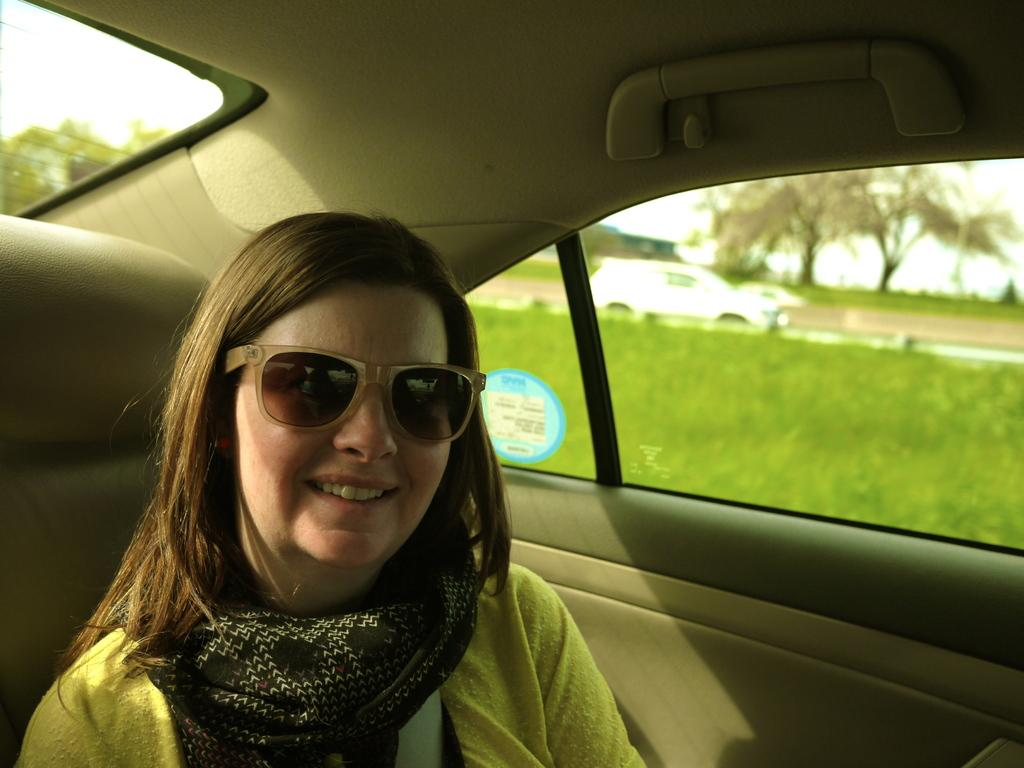What is the person in the car doing? The facts do not specify what the person is doing, but we know that there is a person in the car. What can be inferred about the person's attire? The person is wearing clothes and sunglasses. What is visible in the background of the image? There are trees visible in the image. What type of vehicle is on the right side of the image? There is a car on the right side of the image. What type of soup is the person eating in the car? There is no soup present in the image; the person is wearing sunglasses and there is no mention of food. 